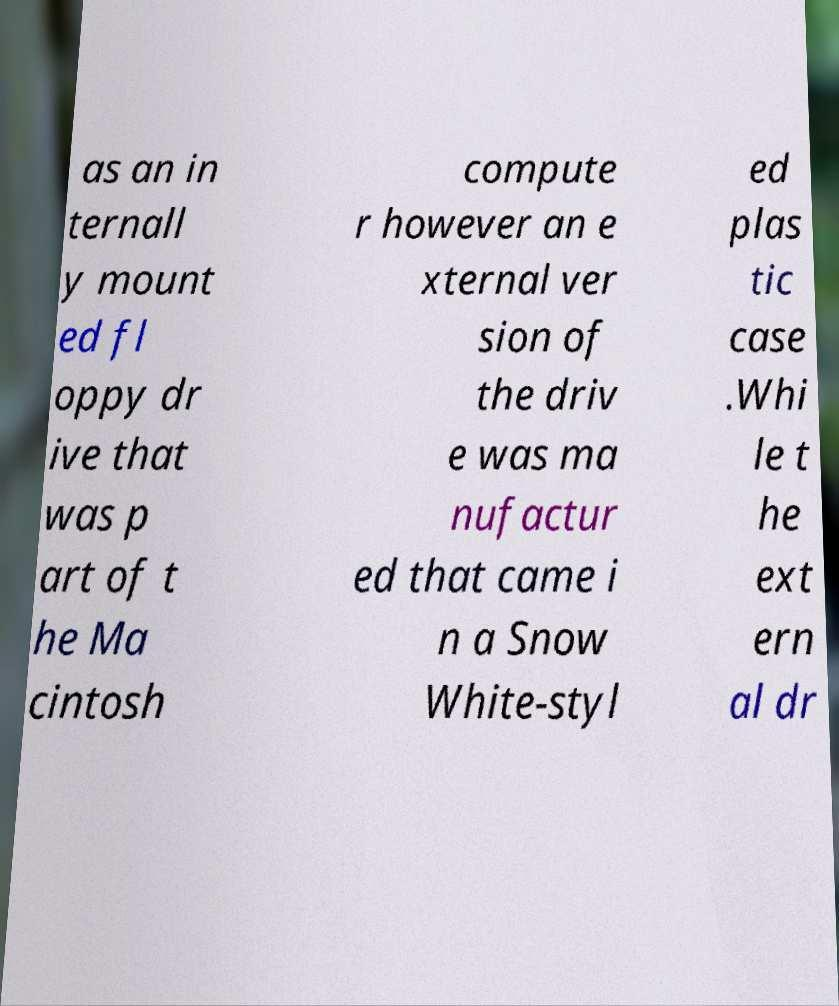Please identify and transcribe the text found in this image. as an in ternall y mount ed fl oppy dr ive that was p art of t he Ma cintosh compute r however an e xternal ver sion of the driv e was ma nufactur ed that came i n a Snow White-styl ed plas tic case .Whi le t he ext ern al dr 